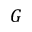<formula> <loc_0><loc_0><loc_500><loc_500>G</formula> 